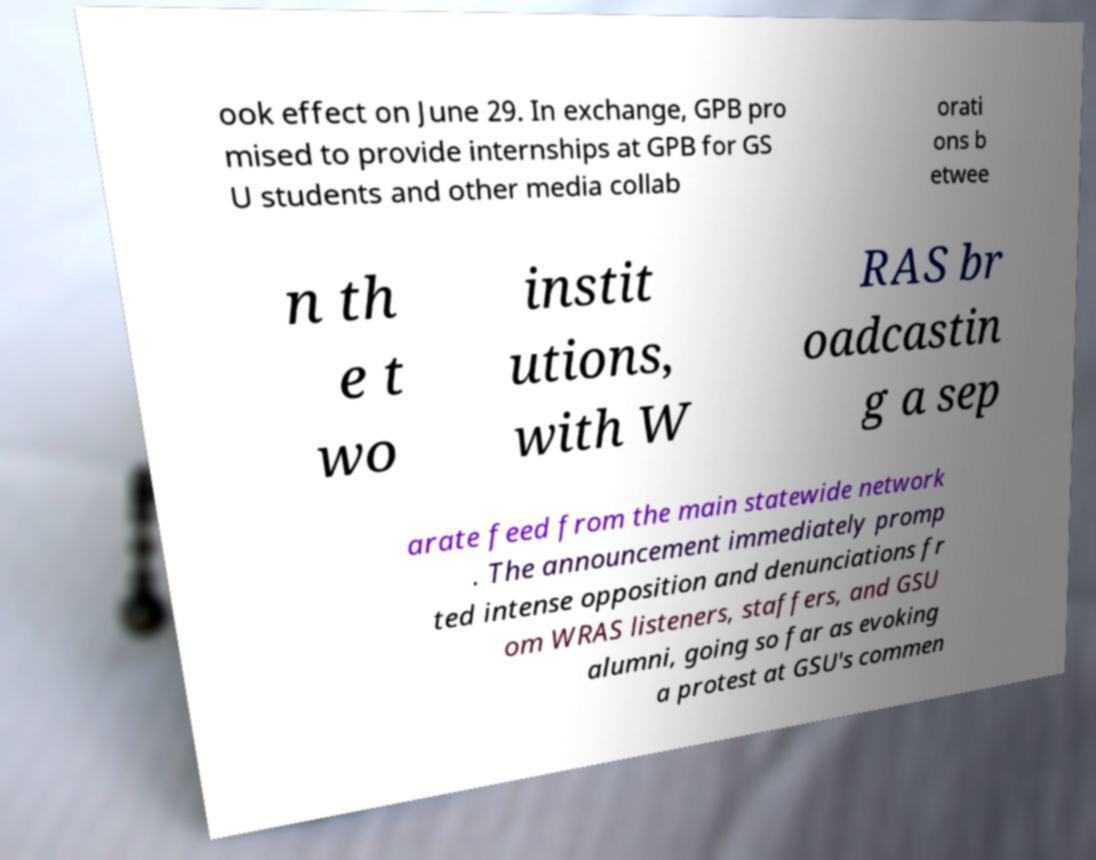Could you assist in decoding the text presented in this image and type it out clearly? ook effect on June 29. In exchange, GPB pro mised to provide internships at GPB for GS U students and other media collab orati ons b etwee n th e t wo instit utions, with W RAS br oadcastin g a sep arate feed from the main statewide network . The announcement immediately promp ted intense opposition and denunciations fr om WRAS listeners, staffers, and GSU alumni, going so far as evoking a protest at GSU's commen 